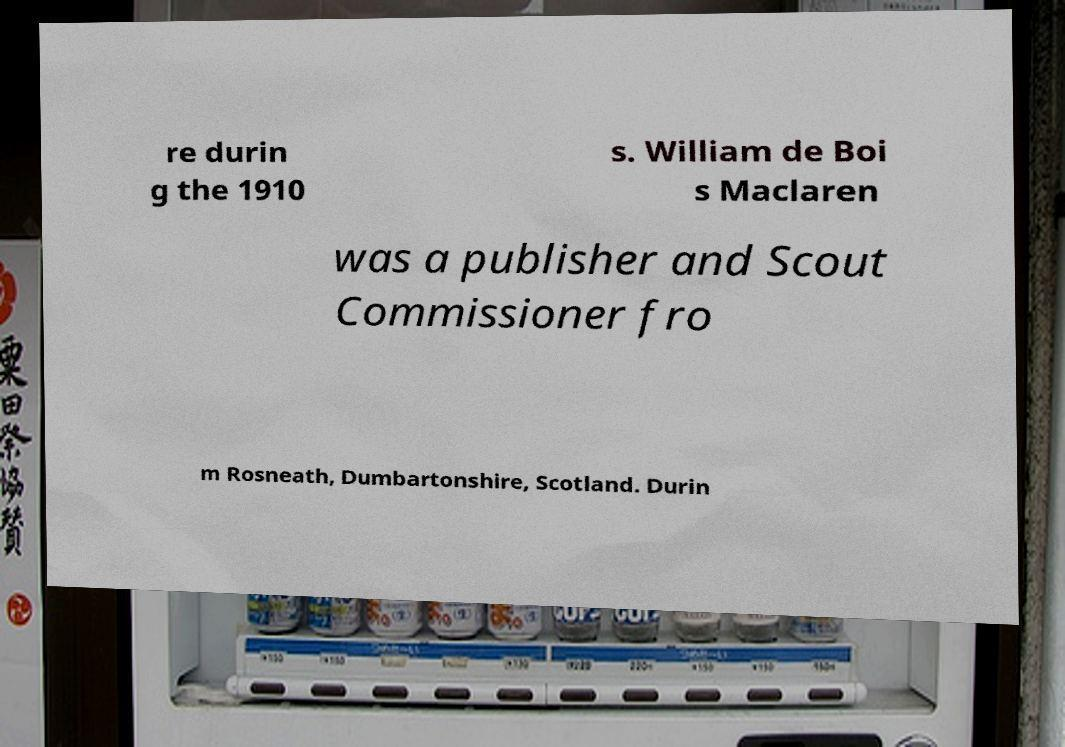Please identify and transcribe the text found in this image. re durin g the 1910 s. William de Boi s Maclaren was a publisher and Scout Commissioner fro m Rosneath, Dumbartonshire, Scotland. Durin 